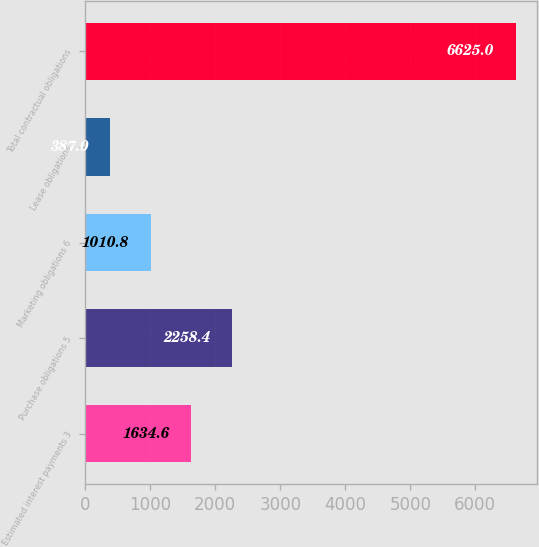Convert chart. <chart><loc_0><loc_0><loc_500><loc_500><bar_chart><fcel>Estimated interest payments 3<fcel>Purchase obligations 5<fcel>Marketing obligations 6<fcel>Lease obligations<fcel>Total contractual obligations<nl><fcel>1634.6<fcel>2258.4<fcel>1010.8<fcel>387<fcel>6625<nl></chart> 